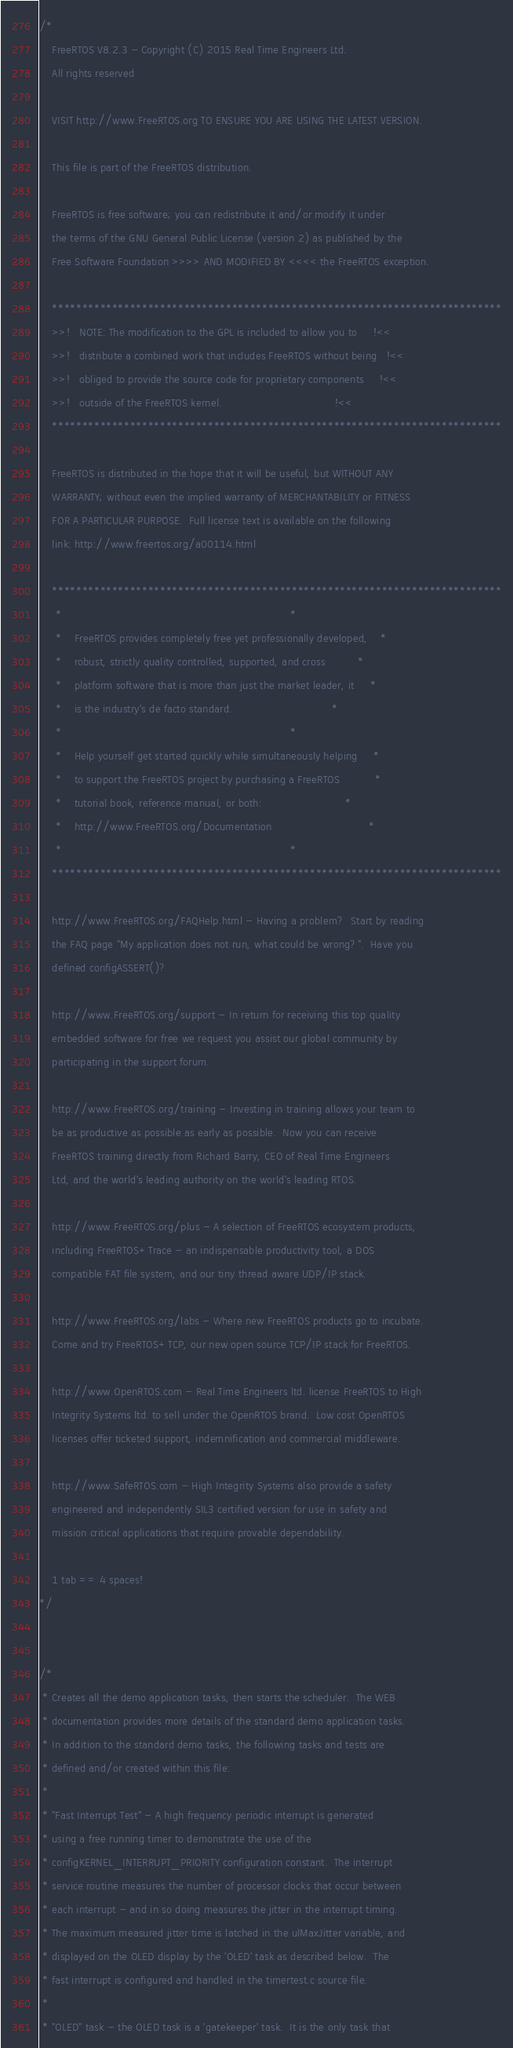<code> <loc_0><loc_0><loc_500><loc_500><_C_>/*
    FreeRTOS V8.2.3 - Copyright (C) 2015 Real Time Engineers Ltd.
    All rights reserved

    VISIT http://www.FreeRTOS.org TO ENSURE YOU ARE USING THE LATEST VERSION.

    This file is part of the FreeRTOS distribution.

    FreeRTOS is free software; you can redistribute it and/or modify it under
    the terms of the GNU General Public License (version 2) as published by the
    Free Software Foundation >>>> AND MODIFIED BY <<<< the FreeRTOS exception.

    ***************************************************************************
    >>!   NOTE: The modification to the GPL is included to allow you to     !<<
    >>!   distribute a combined work that includes FreeRTOS without being   !<<
    >>!   obliged to provide the source code for proprietary components     !<<
    >>!   outside of the FreeRTOS kernel.                                   !<<
    ***************************************************************************

    FreeRTOS is distributed in the hope that it will be useful, but WITHOUT ANY
    WARRANTY; without even the implied warranty of MERCHANTABILITY or FITNESS
    FOR A PARTICULAR PURPOSE.  Full license text is available on the following
    link: http://www.freertos.org/a00114.html

    ***************************************************************************
     *                                                                       *
     *    FreeRTOS provides completely free yet professionally developed,    *
     *    robust, strictly quality controlled, supported, and cross          *
     *    platform software that is more than just the market leader, it     *
     *    is the industry's de facto standard.                               *
     *                                                                       *
     *    Help yourself get started quickly while simultaneously helping     *
     *    to support the FreeRTOS project by purchasing a FreeRTOS           *
     *    tutorial book, reference manual, or both:                          *
     *    http://www.FreeRTOS.org/Documentation                              *
     *                                                                       *
    ***************************************************************************

    http://www.FreeRTOS.org/FAQHelp.html - Having a problem?  Start by reading
    the FAQ page "My application does not run, what could be wrong?".  Have you
    defined configASSERT()?

    http://www.FreeRTOS.org/support - In return for receiving this top quality
    embedded software for free we request you assist our global community by
    participating in the support forum.

    http://www.FreeRTOS.org/training - Investing in training allows your team to
    be as productive as possible as early as possible.  Now you can receive
    FreeRTOS training directly from Richard Barry, CEO of Real Time Engineers
    Ltd, and the world's leading authority on the world's leading RTOS.

    http://www.FreeRTOS.org/plus - A selection of FreeRTOS ecosystem products,
    including FreeRTOS+Trace - an indispensable productivity tool, a DOS
    compatible FAT file system, and our tiny thread aware UDP/IP stack.

    http://www.FreeRTOS.org/labs - Where new FreeRTOS products go to incubate.
    Come and try FreeRTOS+TCP, our new open source TCP/IP stack for FreeRTOS.

    http://www.OpenRTOS.com - Real Time Engineers ltd. license FreeRTOS to High
    Integrity Systems ltd. to sell under the OpenRTOS brand.  Low cost OpenRTOS
    licenses offer ticketed support, indemnification and commercial middleware.

    http://www.SafeRTOS.com - High Integrity Systems also provide a safety
    engineered and independently SIL3 certified version for use in safety and
    mission critical applications that require provable dependability.

    1 tab == 4 spaces!
*/


/*
 * Creates all the demo application tasks, then starts the scheduler.  The WEB
 * documentation provides more details of the standard demo application tasks.
 * In addition to the standard demo tasks, the following tasks and tests are
 * defined and/or created within this file:
 *
 * "Fast Interrupt Test" - A high frequency periodic interrupt is generated
 * using a free running timer to demonstrate the use of the
 * configKERNEL_INTERRUPT_PRIORITY configuration constant.  The interrupt
 * service routine measures the number of processor clocks that occur between
 * each interrupt - and in so doing measures the jitter in the interrupt timing.
 * The maximum measured jitter time is latched in the ulMaxJitter variable, and
 * displayed on the OLED display by the 'OLED' task as described below.  The
 * fast interrupt is configured and handled in the timertest.c source file.
 *
 * "OLED" task - the OLED task is a 'gatekeeper' task.  It is the only task that</code> 